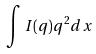<formula> <loc_0><loc_0><loc_500><loc_500>\int I ( q ) q ^ { 2 } d x</formula> 